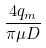<formula> <loc_0><loc_0><loc_500><loc_500>\frac { 4 q _ { m } } { \pi \mu D }</formula> 